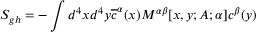Convert formula to latex. <formula><loc_0><loc_0><loc_500><loc_500>S _ { g h } = - \int d ^ { 4 } x d ^ { 4 } y \overline { c } ^ { \alpha } ( x ) M ^ { \alpha \beta } [ x , y ; A ; \alpha ] c ^ { \beta } ( y )</formula> 